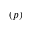Convert formula to latex. <formula><loc_0><loc_0><loc_500><loc_500>( p )</formula> 